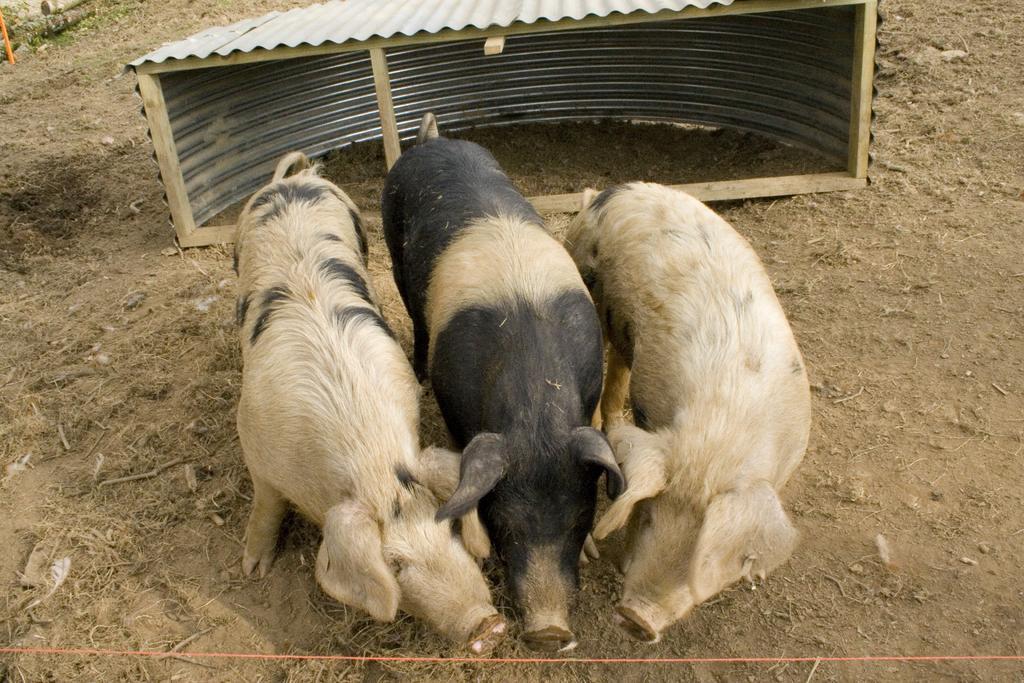Could you give a brief overview of what you see in this image? In this image in the center there are three animals, and in the background there is small shed and at the bottom there is sand and some dry grass. 